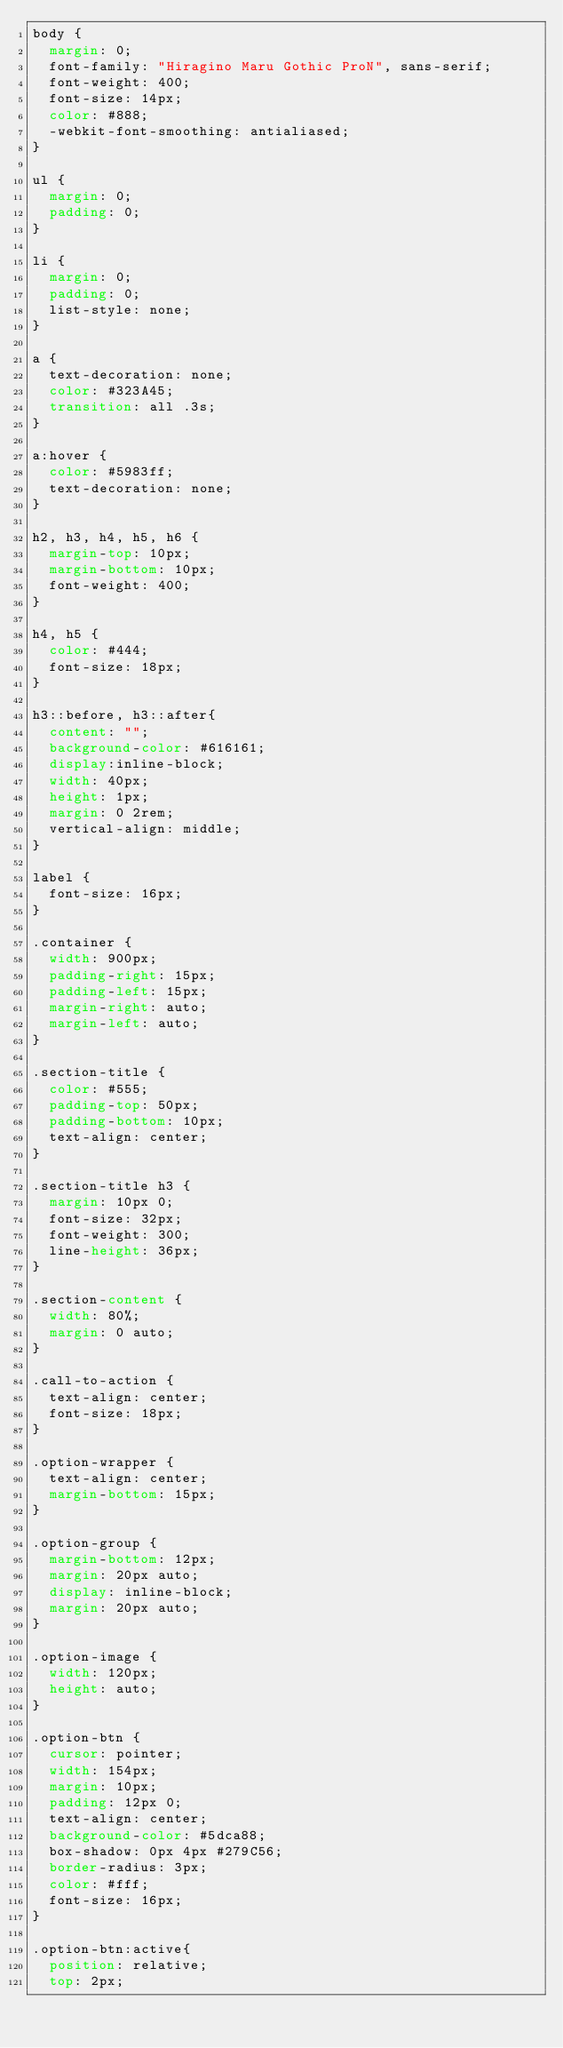Convert code to text. <code><loc_0><loc_0><loc_500><loc_500><_CSS_>body {
  margin: 0;
  font-family: "Hiragino Maru Gothic ProN", sans-serif;
  font-weight: 400;
  font-size: 14px;
  color: #888;
  -webkit-font-smoothing: antialiased;
}

ul {
  margin: 0;
  padding: 0;
}

li {
  margin: 0;
  padding: 0;
  list-style: none;
}

a {
  text-decoration: none;
  color: #323A45;
  transition: all .3s;
}

a:hover {
  color: #5983ff;
  text-decoration: none;
}

h2, h3, h4, h5, h6 {
  margin-top: 10px;
  margin-bottom: 10px;
  font-weight: 400;
}

h4, h5 {
  color: #444;
  font-size: 18px;
}

h3::before, h3::after{
  content: "";
  background-color: #616161;
  display:inline-block;
  width: 40px;
  height: 1px;
  margin: 0 2rem;
  vertical-align: middle;
}

label {
  font-size: 16px;
}

.container {
  width: 900px;
  padding-right: 15px;
  padding-left: 15px;
  margin-right: auto;
  margin-left: auto;
}

.section-title {
  color: #555;
  padding-top: 50px;
  padding-bottom: 10px;
  text-align: center;
}

.section-title h3 {
  margin: 10px 0;
  font-size: 32px;
  font-weight: 300;
  line-height: 36px;
}

.section-content {
  width: 80%;
  margin: 0 auto;
}

.call-to-action {
  text-align: center;
  font-size: 18px;
}

.option-wrapper {
  text-align: center;
  margin-bottom: 15px;
}

.option-group {
  margin-bottom: 12px;
  margin: 20px auto;
  display: inline-block;
  margin: 20px auto;
}

.option-image {
  width: 120px;
  height: auto;
}

.option-btn {
  cursor: pointer;
  width: 154px;
  margin: 10px;
  padding: 12px 0;
  text-align: center;
  background-color: #5dca88;
  box-shadow: 0px 4px #279C56;
  border-radius: 3px;
  color: #fff;
  font-size: 16px;
}

.option-btn:active{
  position: relative;
  top: 2px;</code> 